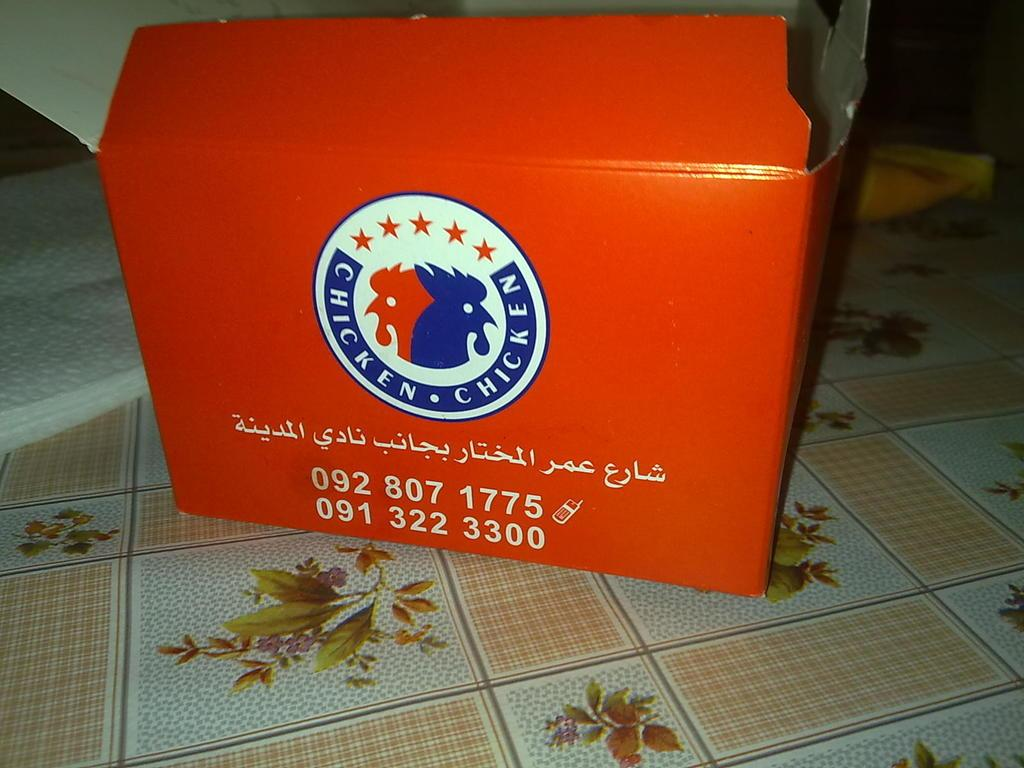Provide a one-sentence caption for the provided image. An orange book with numbers and Chicken Chicken logo. 